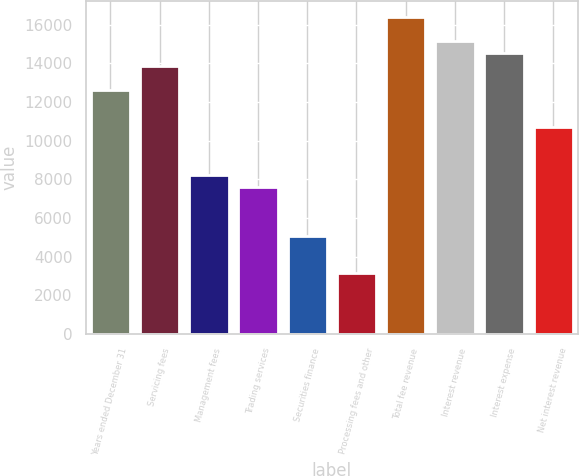Convert chart to OTSL. <chart><loc_0><loc_0><loc_500><loc_500><bar_chart><fcel>Years ended December 31<fcel>Servicing fees<fcel>Management fees<fcel>Trading services<fcel>Securities finance<fcel>Processing fees and other<fcel>Total fee revenue<fcel>Interest revenue<fcel>Interest expense<fcel>Net interest revenue<nl><fcel>12618.7<fcel>13880.2<fcel>8203.27<fcel>7572.5<fcel>5049.42<fcel>3157.11<fcel>16403.3<fcel>15141.7<fcel>14511<fcel>10726.4<nl></chart> 